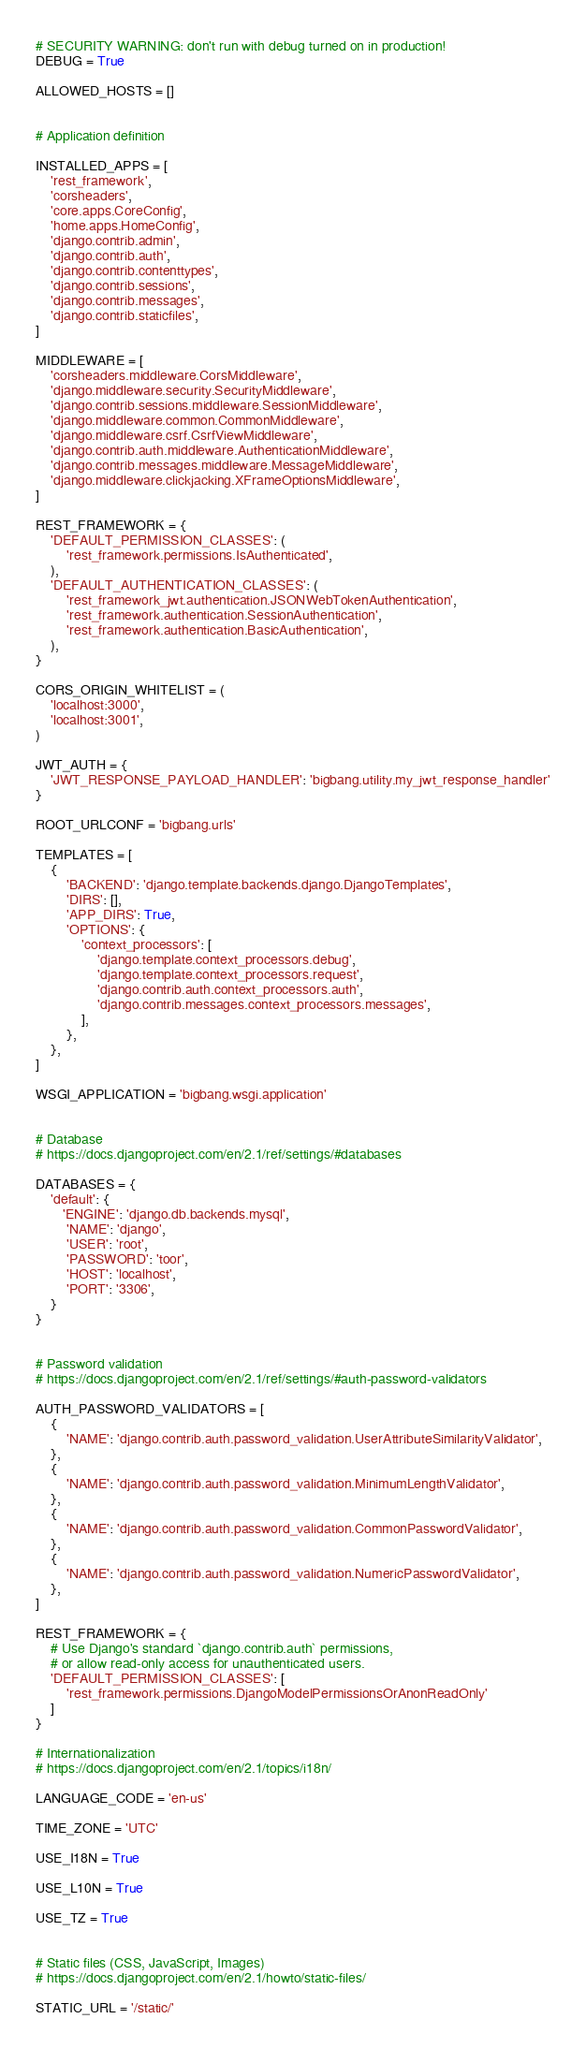<code> <loc_0><loc_0><loc_500><loc_500><_Python_># SECURITY WARNING: don't run with debug turned on in production!
DEBUG = True

ALLOWED_HOSTS = []


# Application definition

INSTALLED_APPS = [
    'rest_framework',
    'corsheaders',
    'core.apps.CoreConfig',
    'home.apps.HomeConfig',
    'django.contrib.admin',
    'django.contrib.auth',
    'django.contrib.contenttypes',
    'django.contrib.sessions',
    'django.contrib.messages',
    'django.contrib.staticfiles',
]

MIDDLEWARE = [
    'corsheaders.middleware.CorsMiddleware', 
    'django.middleware.security.SecurityMiddleware',
    'django.contrib.sessions.middleware.SessionMiddleware',
    'django.middleware.common.CommonMiddleware',
    'django.middleware.csrf.CsrfViewMiddleware',
    'django.contrib.auth.middleware.AuthenticationMiddleware',
    'django.contrib.messages.middleware.MessageMiddleware',
    'django.middleware.clickjacking.XFrameOptionsMiddleware',
]

REST_FRAMEWORK = {
    'DEFAULT_PERMISSION_CLASSES': (
        'rest_framework.permissions.IsAuthenticated',
    ),
    'DEFAULT_AUTHENTICATION_CLASSES': (
        'rest_framework_jwt.authentication.JSONWebTokenAuthentication',
        'rest_framework.authentication.SessionAuthentication',
        'rest_framework.authentication.BasicAuthentication',
    ),
}

CORS_ORIGIN_WHITELIST = (
    'localhost:3000',
    'localhost:3001',
)

JWT_AUTH = {
    'JWT_RESPONSE_PAYLOAD_HANDLER': 'bigbang.utility.my_jwt_response_handler'
}

ROOT_URLCONF = 'bigbang.urls'

TEMPLATES = [
    {
        'BACKEND': 'django.template.backends.django.DjangoTemplates',
        'DIRS': [],
        'APP_DIRS': True,
        'OPTIONS': {
            'context_processors': [
                'django.template.context_processors.debug',
                'django.template.context_processors.request',
                'django.contrib.auth.context_processors.auth',
                'django.contrib.messages.context_processors.messages',
            ],
        },
    },
]

WSGI_APPLICATION = 'bigbang.wsgi.application'


# Database
# https://docs.djangoproject.com/en/2.1/ref/settings/#databases

DATABASES = {
    'default': {
       'ENGINE': 'django.db.backends.mysql',
        'NAME': 'django',
        'USER': 'root',
        'PASSWORD': 'toor',
        'HOST': 'localhost',
        'PORT': '3306',
    }
}


# Password validation
# https://docs.djangoproject.com/en/2.1/ref/settings/#auth-password-validators

AUTH_PASSWORD_VALIDATORS = [
    {
        'NAME': 'django.contrib.auth.password_validation.UserAttributeSimilarityValidator',
    },
    {
        'NAME': 'django.contrib.auth.password_validation.MinimumLengthValidator',
    },
    {
        'NAME': 'django.contrib.auth.password_validation.CommonPasswordValidator',
    },
    {
        'NAME': 'django.contrib.auth.password_validation.NumericPasswordValidator',
    },
]

REST_FRAMEWORK = {
    # Use Django's standard `django.contrib.auth` permissions,
    # or allow read-only access for unauthenticated users.
    'DEFAULT_PERMISSION_CLASSES': [
        'rest_framework.permissions.DjangoModelPermissionsOrAnonReadOnly'
    ]
}

# Internationalization
# https://docs.djangoproject.com/en/2.1/topics/i18n/

LANGUAGE_CODE = 'en-us'

TIME_ZONE = 'UTC'

USE_I18N = True

USE_L10N = True

USE_TZ = True


# Static files (CSS, JavaScript, Images)
# https://docs.djangoproject.com/en/2.1/howto/static-files/

STATIC_URL = '/static/'
</code> 